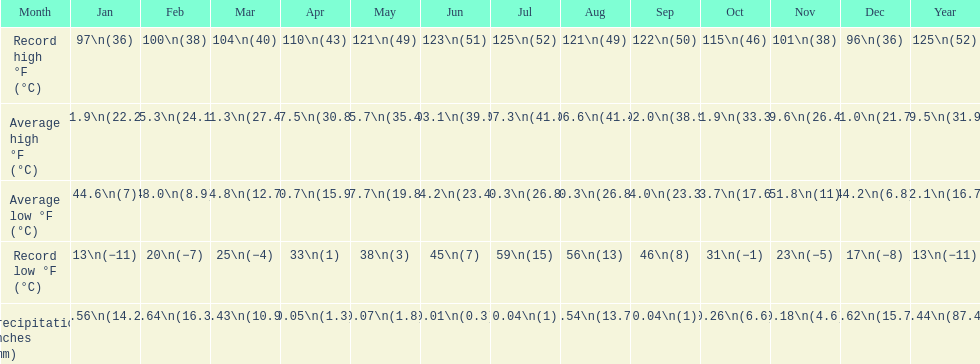How long was the monthly average temperature 100 degrees or more? 4 months. 